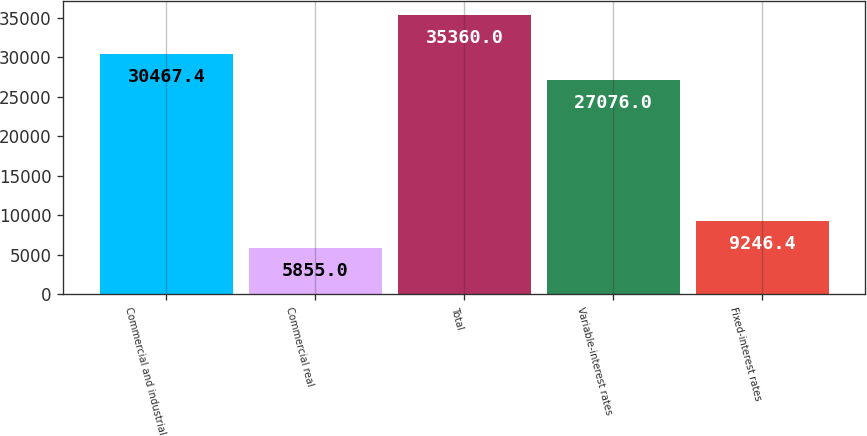Convert chart to OTSL. <chart><loc_0><loc_0><loc_500><loc_500><bar_chart><fcel>Commercial and industrial<fcel>Commercial real<fcel>Total<fcel>Variable-interest rates<fcel>Fixed-interest rates<nl><fcel>30467.4<fcel>5855<fcel>35360<fcel>27076<fcel>9246.4<nl></chart> 